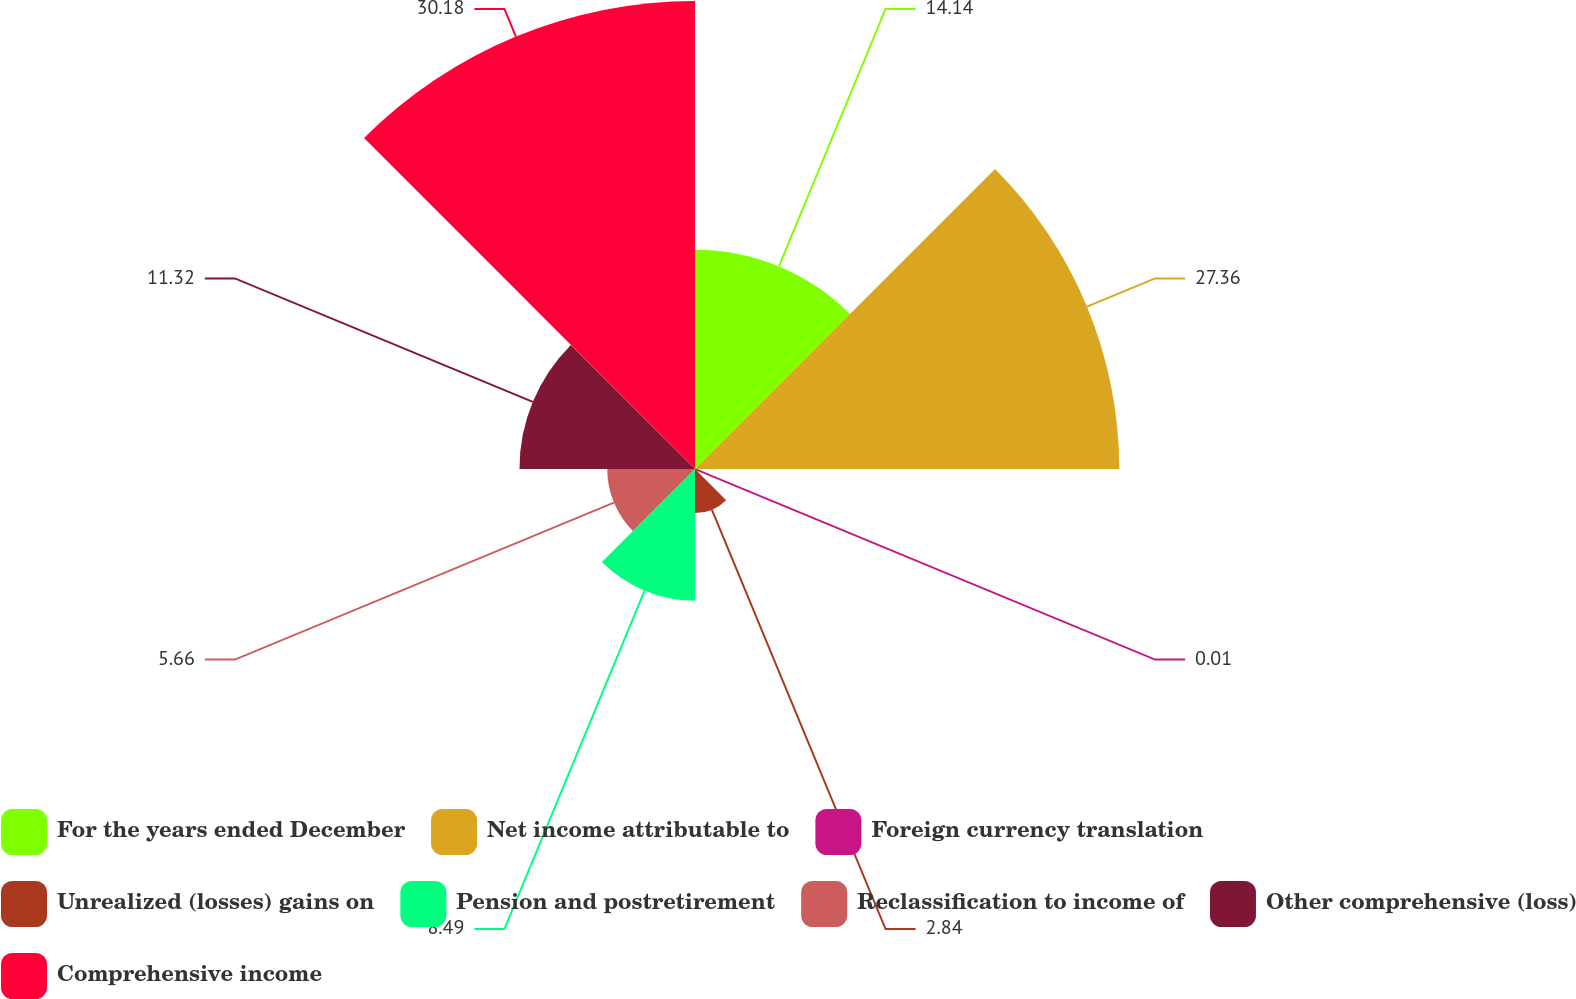Convert chart. <chart><loc_0><loc_0><loc_500><loc_500><pie_chart><fcel>For the years ended December<fcel>Net income attributable to<fcel>Foreign currency translation<fcel>Unrealized (losses) gains on<fcel>Pension and postretirement<fcel>Reclassification to income of<fcel>Other comprehensive (loss)<fcel>Comprehensive income<nl><fcel>14.14%<fcel>27.36%<fcel>0.01%<fcel>2.84%<fcel>8.49%<fcel>5.66%<fcel>11.32%<fcel>30.18%<nl></chart> 